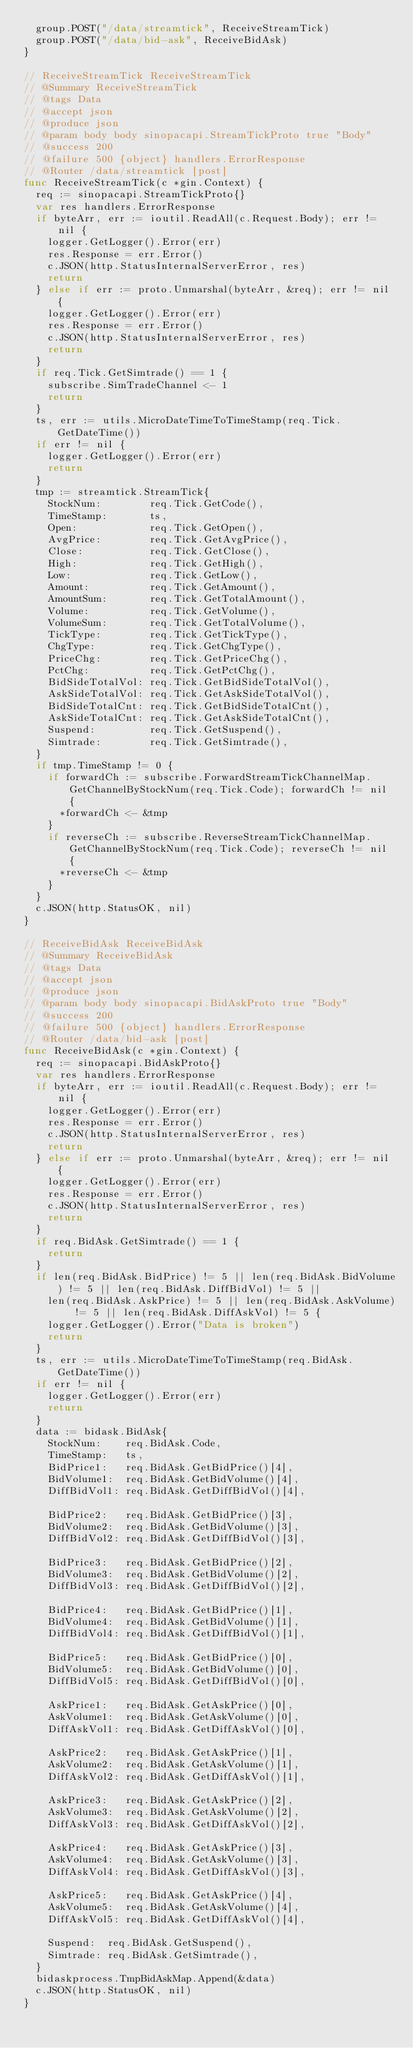Convert code to text. <code><loc_0><loc_0><loc_500><loc_500><_Go_>	group.POST("/data/streamtick", ReceiveStreamTick)
	group.POST("/data/bid-ask", ReceiveBidAsk)
}

// ReceiveStreamTick ReceiveStreamTick
// @Summary ReceiveStreamTick
// @tags Data
// @accept json
// @produce json
// @param body body sinopacapi.StreamTickProto true "Body"
// @success 200
// @failure 500 {object} handlers.ErrorResponse
// @Router /data/streamtick [post]
func ReceiveStreamTick(c *gin.Context) {
	req := sinopacapi.StreamTickProto{}
	var res handlers.ErrorResponse
	if byteArr, err := ioutil.ReadAll(c.Request.Body); err != nil {
		logger.GetLogger().Error(err)
		res.Response = err.Error()
		c.JSON(http.StatusInternalServerError, res)
		return
	} else if err := proto.Unmarshal(byteArr, &req); err != nil {
		logger.GetLogger().Error(err)
		res.Response = err.Error()
		c.JSON(http.StatusInternalServerError, res)
		return
	}
	if req.Tick.GetSimtrade() == 1 {
		subscribe.SimTradeChannel <- 1
		return
	}
	ts, err := utils.MicroDateTimeToTimeStamp(req.Tick.GetDateTime())
	if err != nil {
		logger.GetLogger().Error(err)
		return
	}
	tmp := streamtick.StreamTick{
		StockNum:        req.Tick.GetCode(),
		TimeStamp:       ts,
		Open:            req.Tick.GetOpen(),
		AvgPrice:        req.Tick.GetAvgPrice(),
		Close:           req.Tick.GetClose(),
		High:            req.Tick.GetHigh(),
		Low:             req.Tick.GetLow(),
		Amount:          req.Tick.GetAmount(),
		AmountSum:       req.Tick.GetTotalAmount(),
		Volume:          req.Tick.GetVolume(),
		VolumeSum:       req.Tick.GetTotalVolume(),
		TickType:        req.Tick.GetTickType(),
		ChgType:         req.Tick.GetChgType(),
		PriceChg:        req.Tick.GetPriceChg(),
		PctChg:          req.Tick.GetPctChg(),
		BidSideTotalVol: req.Tick.GetBidSideTotalVol(),
		AskSideTotalVol: req.Tick.GetAskSideTotalVol(),
		BidSideTotalCnt: req.Tick.GetBidSideTotalCnt(),
		AskSideTotalCnt: req.Tick.GetAskSideTotalCnt(),
		Suspend:         req.Tick.GetSuspend(),
		Simtrade:        req.Tick.GetSimtrade(),
	}
	if tmp.TimeStamp != 0 {
		if forwardCh := subscribe.ForwardStreamTickChannelMap.GetChannelByStockNum(req.Tick.Code); forwardCh != nil {
			*forwardCh <- &tmp
		}
		if reverseCh := subscribe.ReverseStreamTickChannelMap.GetChannelByStockNum(req.Tick.Code); reverseCh != nil {
			*reverseCh <- &tmp
		}
	}
	c.JSON(http.StatusOK, nil)
}

// ReceiveBidAsk ReceiveBidAsk
// @Summary ReceiveBidAsk
// @tags Data
// @accept json
// @produce json
// @param body body sinopacapi.BidAskProto true "Body"
// @success 200
// @failure 500 {object} handlers.ErrorResponse
// @Router /data/bid-ask [post]
func ReceiveBidAsk(c *gin.Context) {
	req := sinopacapi.BidAskProto{}
	var res handlers.ErrorResponse
	if byteArr, err := ioutil.ReadAll(c.Request.Body); err != nil {
		logger.GetLogger().Error(err)
		res.Response = err.Error()
		c.JSON(http.StatusInternalServerError, res)
		return
	} else if err := proto.Unmarshal(byteArr, &req); err != nil {
		logger.GetLogger().Error(err)
		res.Response = err.Error()
		c.JSON(http.StatusInternalServerError, res)
		return
	}
	if req.BidAsk.GetSimtrade() == 1 {
		return
	}
	if len(req.BidAsk.BidPrice) != 5 || len(req.BidAsk.BidVolume) != 5 || len(req.BidAsk.DiffBidVol) != 5 ||
		len(req.BidAsk.AskPrice) != 5 || len(req.BidAsk.AskVolume) != 5 || len(req.BidAsk.DiffAskVol) != 5 {
		logger.GetLogger().Error("Data is broken")
		return
	}
	ts, err := utils.MicroDateTimeToTimeStamp(req.BidAsk.GetDateTime())
	if err != nil {
		logger.GetLogger().Error(err)
		return
	}
	data := bidask.BidAsk{
		StockNum:    req.BidAsk.Code,
		TimeStamp:   ts,
		BidPrice1:   req.BidAsk.GetBidPrice()[4],
		BidVolume1:  req.BidAsk.GetBidVolume()[4],
		DiffBidVol1: req.BidAsk.GetDiffBidVol()[4],

		BidPrice2:   req.BidAsk.GetBidPrice()[3],
		BidVolume2:  req.BidAsk.GetBidVolume()[3],
		DiffBidVol2: req.BidAsk.GetDiffBidVol()[3],

		BidPrice3:   req.BidAsk.GetBidPrice()[2],
		BidVolume3:  req.BidAsk.GetBidVolume()[2],
		DiffBidVol3: req.BidAsk.GetDiffBidVol()[2],

		BidPrice4:   req.BidAsk.GetBidPrice()[1],
		BidVolume4:  req.BidAsk.GetBidVolume()[1],
		DiffBidVol4: req.BidAsk.GetDiffBidVol()[1],

		BidPrice5:   req.BidAsk.GetBidPrice()[0],
		BidVolume5:  req.BidAsk.GetBidVolume()[0],
		DiffBidVol5: req.BidAsk.GetDiffBidVol()[0],

		AskPrice1:   req.BidAsk.GetAskPrice()[0],
		AskVolume1:  req.BidAsk.GetAskVolume()[0],
		DiffAskVol1: req.BidAsk.GetDiffAskVol()[0],

		AskPrice2:   req.BidAsk.GetAskPrice()[1],
		AskVolume2:  req.BidAsk.GetAskVolume()[1],
		DiffAskVol2: req.BidAsk.GetDiffAskVol()[1],

		AskPrice3:   req.BidAsk.GetAskPrice()[2],
		AskVolume3:  req.BidAsk.GetAskVolume()[2],
		DiffAskVol3: req.BidAsk.GetDiffAskVol()[2],

		AskPrice4:   req.BidAsk.GetAskPrice()[3],
		AskVolume4:  req.BidAsk.GetAskVolume()[3],
		DiffAskVol4: req.BidAsk.GetDiffAskVol()[3],

		AskPrice5:   req.BidAsk.GetAskPrice()[4],
		AskVolume5:  req.BidAsk.GetAskVolume()[4],
		DiffAskVol5: req.BidAsk.GetDiffAskVol()[4],

		Suspend:  req.BidAsk.GetSuspend(),
		Simtrade: req.BidAsk.GetSimtrade(),
	}
	bidaskprocess.TmpBidAskMap.Append(&data)
	c.JSON(http.StatusOK, nil)
}
</code> 